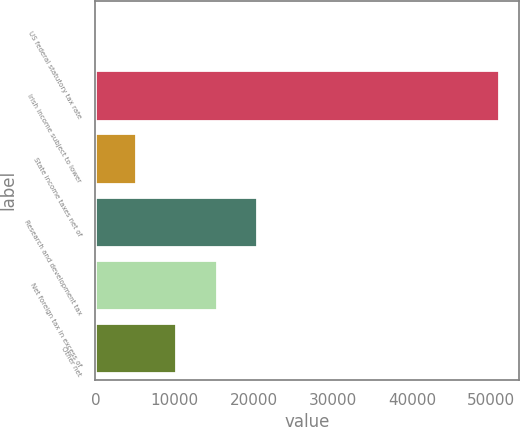Convert chart to OTSL. <chart><loc_0><loc_0><loc_500><loc_500><bar_chart><fcel>US federal statutory tax rate<fcel>Irish income subject to lower<fcel>State income taxes net of<fcel>Research and development tax<fcel>Net foreign tax in excess of<fcel>Other net<nl><fcel>35<fcel>50972<fcel>5128.7<fcel>20409.8<fcel>15316.1<fcel>10222.4<nl></chart> 